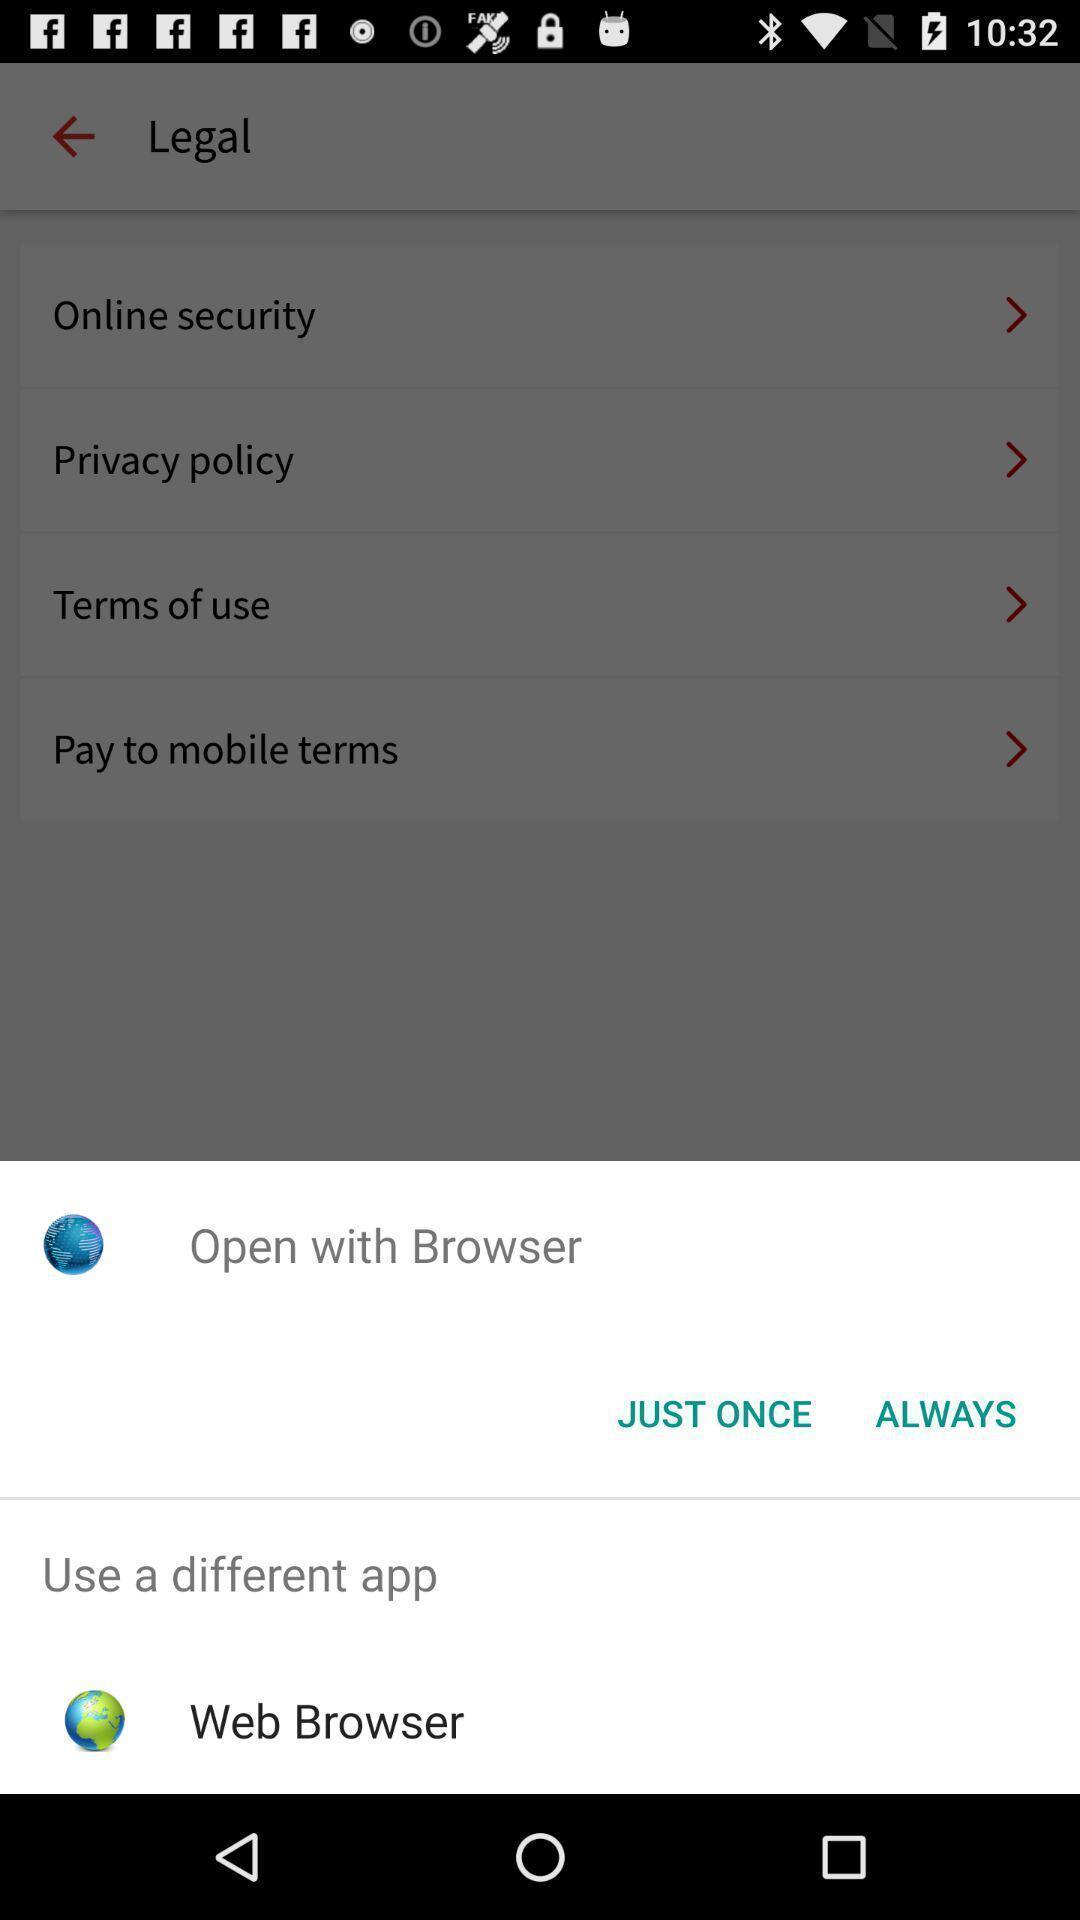Please provide a description for this image. Pop up showing an application to open. 